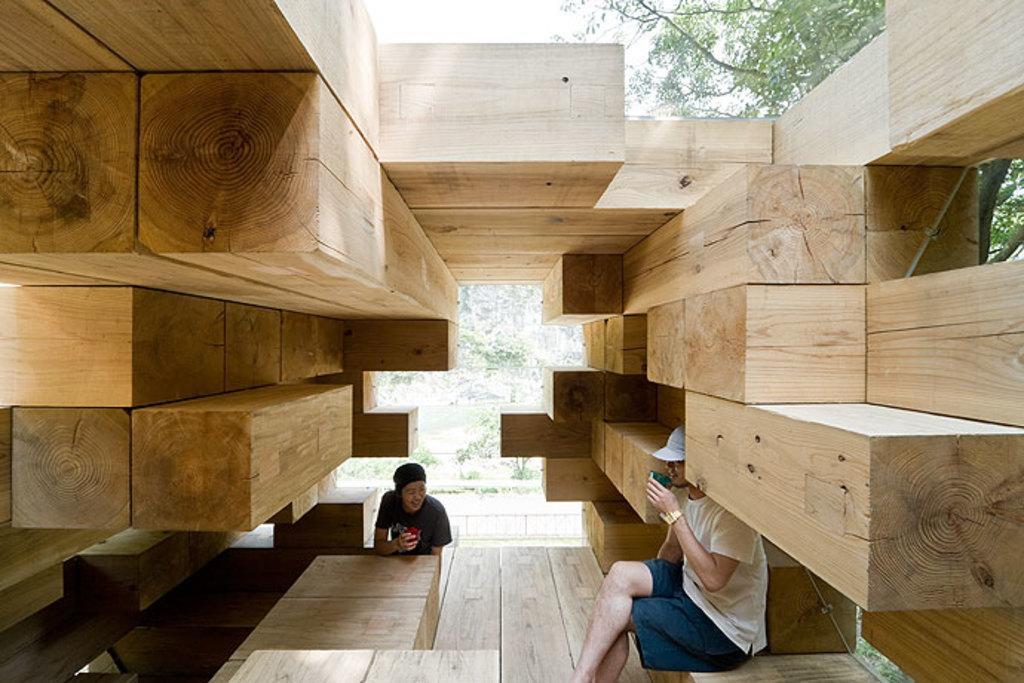In one or two sentences, can you explain what this image depicts? In this picture we can see there are two people sitting on the wooden objects. Behind the wooden objects there are trees. 